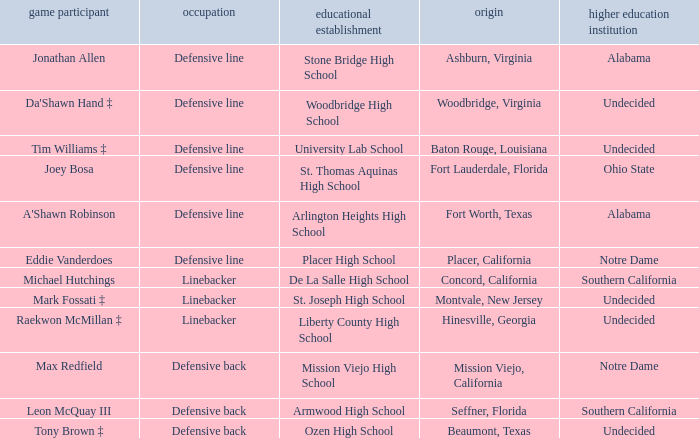What is the position of the player from Fort Lauderdale, Florida? Defensive line. 